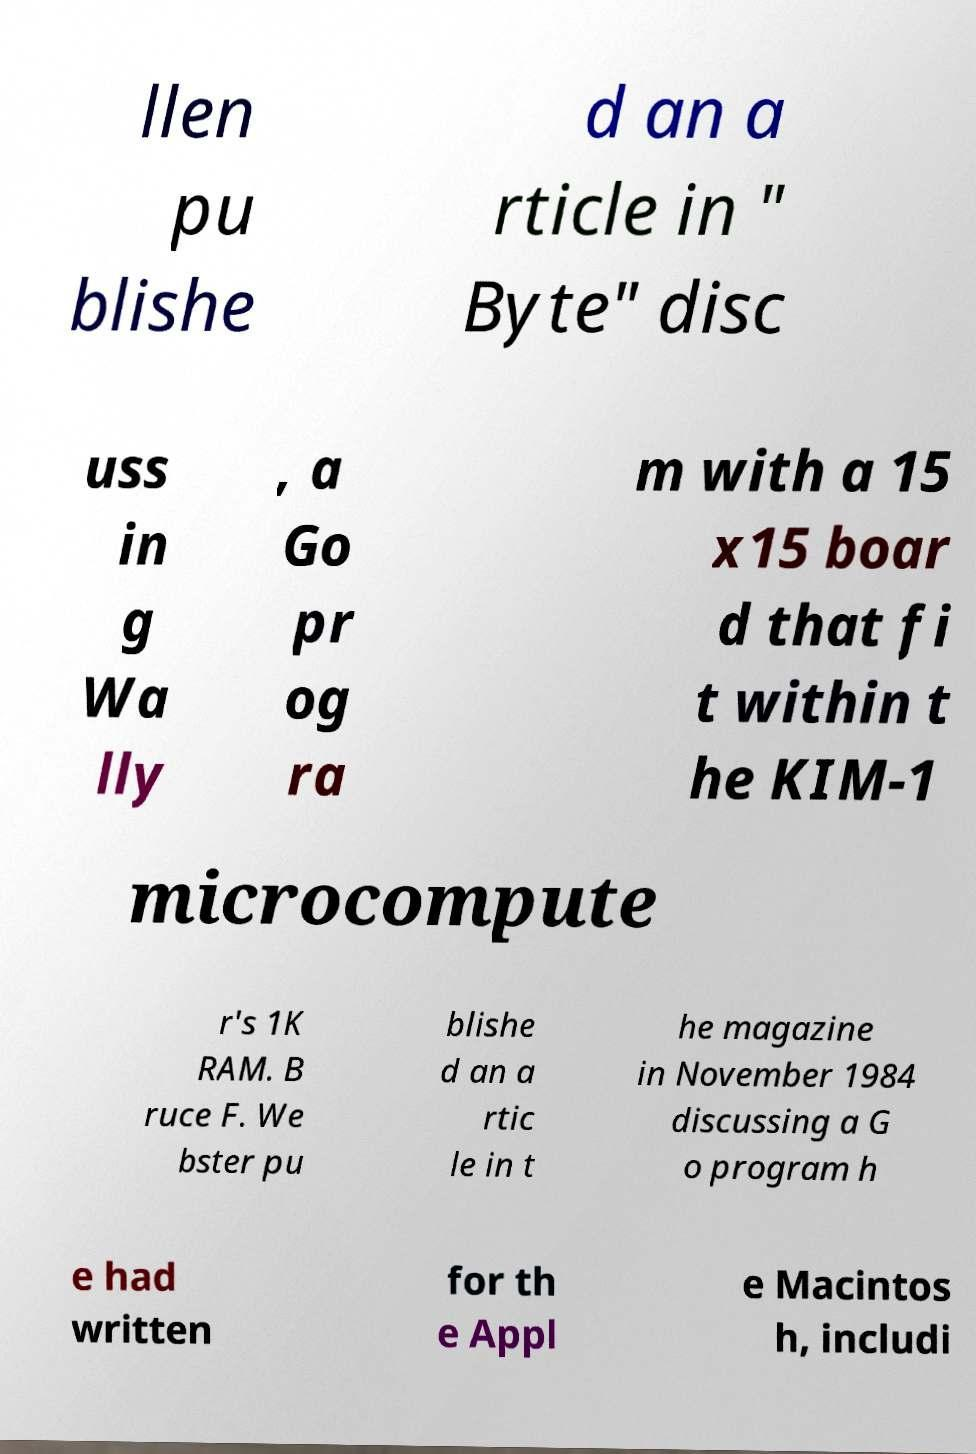Please read and relay the text visible in this image. What does it say? llen pu blishe d an a rticle in " Byte" disc uss in g Wa lly , a Go pr og ra m with a 15 x15 boar d that fi t within t he KIM-1 microcompute r's 1K RAM. B ruce F. We bster pu blishe d an a rtic le in t he magazine in November 1984 discussing a G o program h e had written for th e Appl e Macintos h, includi 